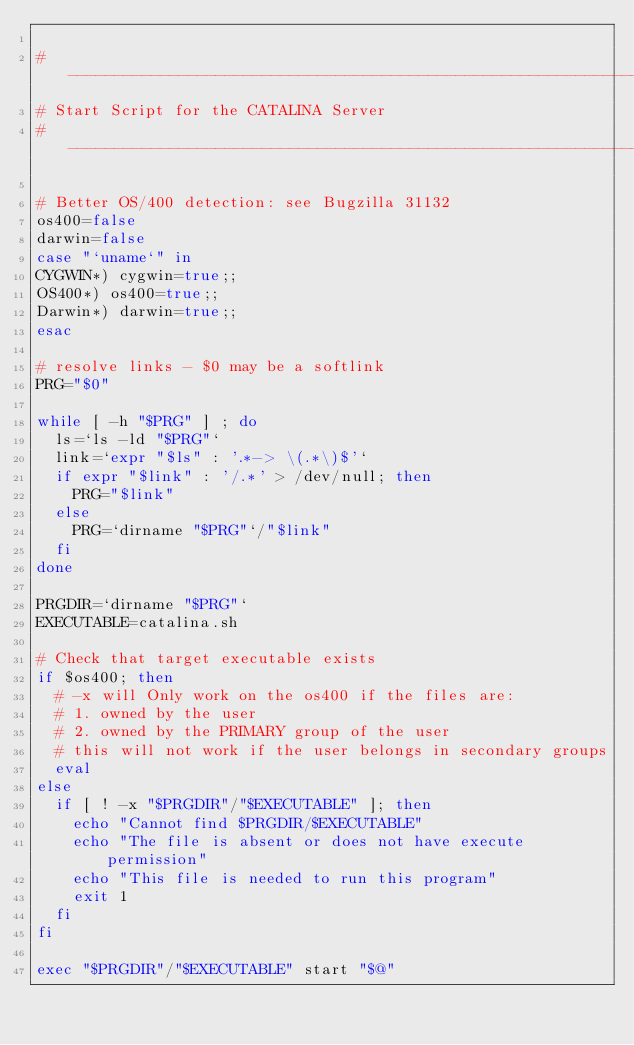<code> <loc_0><loc_0><loc_500><loc_500><_Bash_>
# -----------------------------------------------------------------------------
# Start Script for the CATALINA Server
# -----------------------------------------------------------------------------

# Better OS/400 detection: see Bugzilla 31132
os400=false
darwin=false
case "`uname`" in
CYGWIN*) cygwin=true;;
OS400*) os400=true;;
Darwin*) darwin=true;;
esac

# resolve links - $0 may be a softlink
PRG="$0"

while [ -h "$PRG" ] ; do
  ls=`ls -ld "$PRG"`
  link=`expr "$ls" : '.*-> \(.*\)$'`
  if expr "$link" : '/.*' > /dev/null; then
    PRG="$link"
  else
    PRG=`dirname "$PRG"`/"$link"
  fi
done
 
PRGDIR=`dirname "$PRG"`
EXECUTABLE=catalina.sh

# Check that target executable exists
if $os400; then
  # -x will Only work on the os400 if the files are: 
  # 1. owned by the user
  # 2. owned by the PRIMARY group of the user
  # this will not work if the user belongs in secondary groups
  eval
else
  if [ ! -x "$PRGDIR"/"$EXECUTABLE" ]; then
    echo "Cannot find $PRGDIR/$EXECUTABLE"
    echo "The file is absent or does not have execute permission"
    echo "This file is needed to run this program"
    exit 1
  fi
fi 

exec "$PRGDIR"/"$EXECUTABLE" start "$@"
</code> 